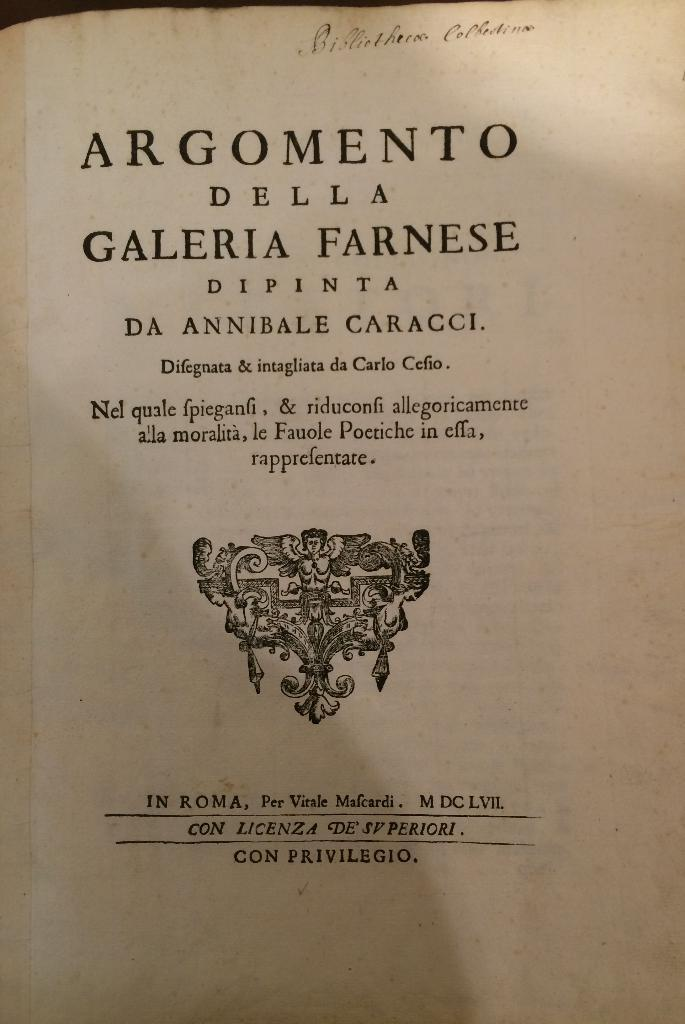<image>
Render a clear and concise summary of the photo. A book written in Italian sits open to its title page. 